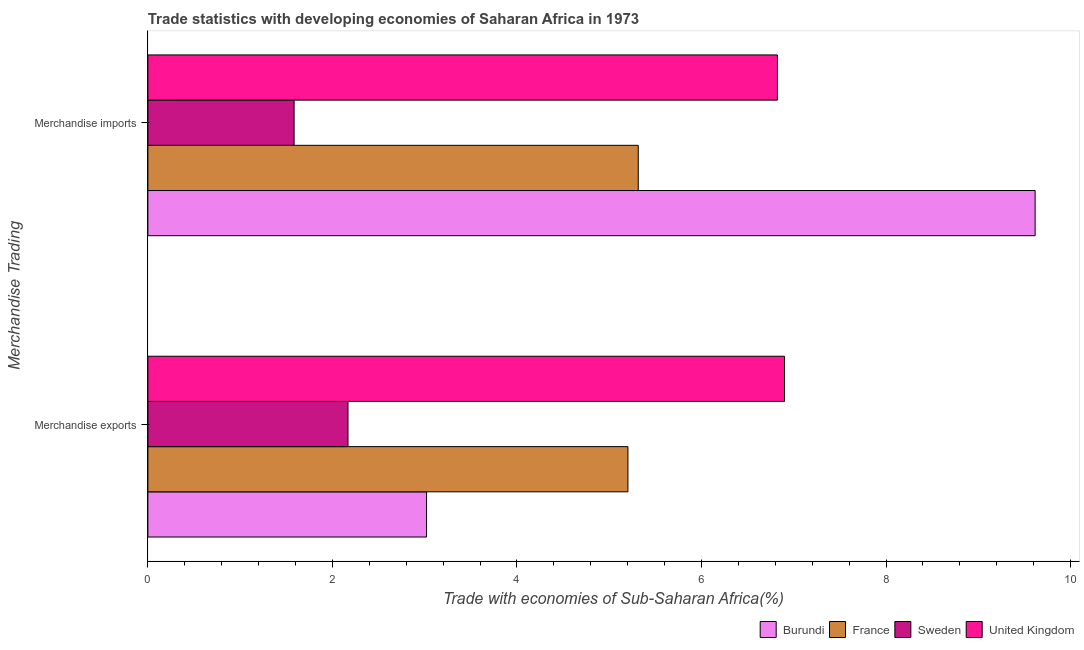How many different coloured bars are there?
Offer a very short reply. 4. Are the number of bars per tick equal to the number of legend labels?
Your response must be concise. Yes. What is the label of the 1st group of bars from the top?
Make the answer very short. Merchandise imports. What is the merchandise exports in United Kingdom?
Ensure brevity in your answer.  6.9. Across all countries, what is the maximum merchandise exports?
Your answer should be very brief. 6.9. Across all countries, what is the minimum merchandise exports?
Give a very brief answer. 2.17. In which country was the merchandise exports maximum?
Provide a succinct answer. United Kingdom. In which country was the merchandise exports minimum?
Give a very brief answer. Sweden. What is the total merchandise imports in the graph?
Keep it short and to the point. 23.34. What is the difference between the merchandise imports in Sweden and that in United Kingdom?
Offer a very short reply. -5.24. What is the difference between the merchandise exports in Sweden and the merchandise imports in France?
Give a very brief answer. -3.15. What is the average merchandise exports per country?
Keep it short and to the point. 4.32. What is the difference between the merchandise imports and merchandise exports in France?
Offer a terse response. 0.11. What is the ratio of the merchandise imports in United Kingdom to that in France?
Provide a succinct answer. 1.28. In how many countries, is the merchandise imports greater than the average merchandise imports taken over all countries?
Offer a very short reply. 2. What does the 1st bar from the bottom in Merchandise imports represents?
Provide a succinct answer. Burundi. How many bars are there?
Ensure brevity in your answer.  8. How many countries are there in the graph?
Provide a short and direct response. 4. Does the graph contain any zero values?
Offer a terse response. No. Where does the legend appear in the graph?
Make the answer very short. Bottom right. What is the title of the graph?
Give a very brief answer. Trade statistics with developing economies of Saharan Africa in 1973. What is the label or title of the X-axis?
Provide a short and direct response. Trade with economies of Sub-Saharan Africa(%). What is the label or title of the Y-axis?
Offer a very short reply. Merchandise Trading. What is the Trade with economies of Sub-Saharan Africa(%) of Burundi in Merchandise exports?
Keep it short and to the point. 3.02. What is the Trade with economies of Sub-Saharan Africa(%) of France in Merchandise exports?
Offer a very short reply. 5.2. What is the Trade with economies of Sub-Saharan Africa(%) of Sweden in Merchandise exports?
Your response must be concise. 2.17. What is the Trade with economies of Sub-Saharan Africa(%) in United Kingdom in Merchandise exports?
Your response must be concise. 6.9. What is the Trade with economies of Sub-Saharan Africa(%) in Burundi in Merchandise imports?
Make the answer very short. 9.62. What is the Trade with economies of Sub-Saharan Africa(%) in France in Merchandise imports?
Give a very brief answer. 5.31. What is the Trade with economies of Sub-Saharan Africa(%) in Sweden in Merchandise imports?
Give a very brief answer. 1.58. What is the Trade with economies of Sub-Saharan Africa(%) of United Kingdom in Merchandise imports?
Provide a succinct answer. 6.82. Across all Merchandise Trading, what is the maximum Trade with economies of Sub-Saharan Africa(%) of Burundi?
Your answer should be compact. 9.62. Across all Merchandise Trading, what is the maximum Trade with economies of Sub-Saharan Africa(%) of France?
Your response must be concise. 5.31. Across all Merchandise Trading, what is the maximum Trade with economies of Sub-Saharan Africa(%) of Sweden?
Make the answer very short. 2.17. Across all Merchandise Trading, what is the maximum Trade with economies of Sub-Saharan Africa(%) in United Kingdom?
Your answer should be compact. 6.9. Across all Merchandise Trading, what is the minimum Trade with economies of Sub-Saharan Africa(%) in Burundi?
Provide a succinct answer. 3.02. Across all Merchandise Trading, what is the minimum Trade with economies of Sub-Saharan Africa(%) in France?
Give a very brief answer. 5.2. Across all Merchandise Trading, what is the minimum Trade with economies of Sub-Saharan Africa(%) in Sweden?
Your response must be concise. 1.58. Across all Merchandise Trading, what is the minimum Trade with economies of Sub-Saharan Africa(%) of United Kingdom?
Your response must be concise. 6.82. What is the total Trade with economies of Sub-Saharan Africa(%) in Burundi in the graph?
Your answer should be very brief. 12.64. What is the total Trade with economies of Sub-Saharan Africa(%) in France in the graph?
Make the answer very short. 10.52. What is the total Trade with economies of Sub-Saharan Africa(%) of Sweden in the graph?
Your answer should be compact. 3.75. What is the total Trade with economies of Sub-Saharan Africa(%) in United Kingdom in the graph?
Your response must be concise. 13.72. What is the difference between the Trade with economies of Sub-Saharan Africa(%) of Burundi in Merchandise exports and that in Merchandise imports?
Your answer should be very brief. -6.6. What is the difference between the Trade with economies of Sub-Saharan Africa(%) of France in Merchandise exports and that in Merchandise imports?
Provide a short and direct response. -0.11. What is the difference between the Trade with economies of Sub-Saharan Africa(%) of Sweden in Merchandise exports and that in Merchandise imports?
Your response must be concise. 0.58. What is the difference between the Trade with economies of Sub-Saharan Africa(%) in United Kingdom in Merchandise exports and that in Merchandise imports?
Give a very brief answer. 0.08. What is the difference between the Trade with economies of Sub-Saharan Africa(%) of Burundi in Merchandise exports and the Trade with economies of Sub-Saharan Africa(%) of France in Merchandise imports?
Ensure brevity in your answer.  -2.29. What is the difference between the Trade with economies of Sub-Saharan Africa(%) in Burundi in Merchandise exports and the Trade with economies of Sub-Saharan Africa(%) in Sweden in Merchandise imports?
Ensure brevity in your answer.  1.44. What is the difference between the Trade with economies of Sub-Saharan Africa(%) in Burundi in Merchandise exports and the Trade with economies of Sub-Saharan Africa(%) in United Kingdom in Merchandise imports?
Ensure brevity in your answer.  -3.8. What is the difference between the Trade with economies of Sub-Saharan Africa(%) in France in Merchandise exports and the Trade with economies of Sub-Saharan Africa(%) in Sweden in Merchandise imports?
Offer a terse response. 3.62. What is the difference between the Trade with economies of Sub-Saharan Africa(%) in France in Merchandise exports and the Trade with economies of Sub-Saharan Africa(%) in United Kingdom in Merchandise imports?
Make the answer very short. -1.62. What is the difference between the Trade with economies of Sub-Saharan Africa(%) of Sweden in Merchandise exports and the Trade with economies of Sub-Saharan Africa(%) of United Kingdom in Merchandise imports?
Your answer should be compact. -4.65. What is the average Trade with economies of Sub-Saharan Africa(%) of Burundi per Merchandise Trading?
Your response must be concise. 6.32. What is the average Trade with economies of Sub-Saharan Africa(%) in France per Merchandise Trading?
Provide a succinct answer. 5.26. What is the average Trade with economies of Sub-Saharan Africa(%) in Sweden per Merchandise Trading?
Offer a very short reply. 1.88. What is the average Trade with economies of Sub-Saharan Africa(%) in United Kingdom per Merchandise Trading?
Offer a very short reply. 6.86. What is the difference between the Trade with economies of Sub-Saharan Africa(%) in Burundi and Trade with economies of Sub-Saharan Africa(%) in France in Merchandise exports?
Your answer should be very brief. -2.18. What is the difference between the Trade with economies of Sub-Saharan Africa(%) of Burundi and Trade with economies of Sub-Saharan Africa(%) of Sweden in Merchandise exports?
Your response must be concise. 0.85. What is the difference between the Trade with economies of Sub-Saharan Africa(%) in Burundi and Trade with economies of Sub-Saharan Africa(%) in United Kingdom in Merchandise exports?
Your response must be concise. -3.88. What is the difference between the Trade with economies of Sub-Saharan Africa(%) in France and Trade with economies of Sub-Saharan Africa(%) in Sweden in Merchandise exports?
Ensure brevity in your answer.  3.03. What is the difference between the Trade with economies of Sub-Saharan Africa(%) of France and Trade with economies of Sub-Saharan Africa(%) of United Kingdom in Merchandise exports?
Offer a very short reply. -1.7. What is the difference between the Trade with economies of Sub-Saharan Africa(%) in Sweden and Trade with economies of Sub-Saharan Africa(%) in United Kingdom in Merchandise exports?
Make the answer very short. -4.73. What is the difference between the Trade with economies of Sub-Saharan Africa(%) in Burundi and Trade with economies of Sub-Saharan Africa(%) in France in Merchandise imports?
Provide a succinct answer. 4.3. What is the difference between the Trade with economies of Sub-Saharan Africa(%) of Burundi and Trade with economies of Sub-Saharan Africa(%) of Sweden in Merchandise imports?
Offer a very short reply. 8.03. What is the difference between the Trade with economies of Sub-Saharan Africa(%) of Burundi and Trade with economies of Sub-Saharan Africa(%) of United Kingdom in Merchandise imports?
Give a very brief answer. 2.79. What is the difference between the Trade with economies of Sub-Saharan Africa(%) in France and Trade with economies of Sub-Saharan Africa(%) in Sweden in Merchandise imports?
Your response must be concise. 3.73. What is the difference between the Trade with economies of Sub-Saharan Africa(%) of France and Trade with economies of Sub-Saharan Africa(%) of United Kingdom in Merchandise imports?
Give a very brief answer. -1.51. What is the difference between the Trade with economies of Sub-Saharan Africa(%) of Sweden and Trade with economies of Sub-Saharan Africa(%) of United Kingdom in Merchandise imports?
Make the answer very short. -5.24. What is the ratio of the Trade with economies of Sub-Saharan Africa(%) of Burundi in Merchandise exports to that in Merchandise imports?
Your response must be concise. 0.31. What is the ratio of the Trade with economies of Sub-Saharan Africa(%) in France in Merchandise exports to that in Merchandise imports?
Keep it short and to the point. 0.98. What is the ratio of the Trade with economies of Sub-Saharan Africa(%) in Sweden in Merchandise exports to that in Merchandise imports?
Give a very brief answer. 1.37. What is the ratio of the Trade with economies of Sub-Saharan Africa(%) of United Kingdom in Merchandise exports to that in Merchandise imports?
Provide a succinct answer. 1.01. What is the difference between the highest and the second highest Trade with economies of Sub-Saharan Africa(%) in Burundi?
Your response must be concise. 6.6. What is the difference between the highest and the second highest Trade with economies of Sub-Saharan Africa(%) in France?
Your answer should be very brief. 0.11. What is the difference between the highest and the second highest Trade with economies of Sub-Saharan Africa(%) in Sweden?
Make the answer very short. 0.58. What is the difference between the highest and the second highest Trade with economies of Sub-Saharan Africa(%) in United Kingdom?
Give a very brief answer. 0.08. What is the difference between the highest and the lowest Trade with economies of Sub-Saharan Africa(%) in Burundi?
Provide a short and direct response. 6.6. What is the difference between the highest and the lowest Trade with economies of Sub-Saharan Africa(%) of France?
Your response must be concise. 0.11. What is the difference between the highest and the lowest Trade with economies of Sub-Saharan Africa(%) in Sweden?
Keep it short and to the point. 0.58. What is the difference between the highest and the lowest Trade with economies of Sub-Saharan Africa(%) in United Kingdom?
Provide a succinct answer. 0.08. 